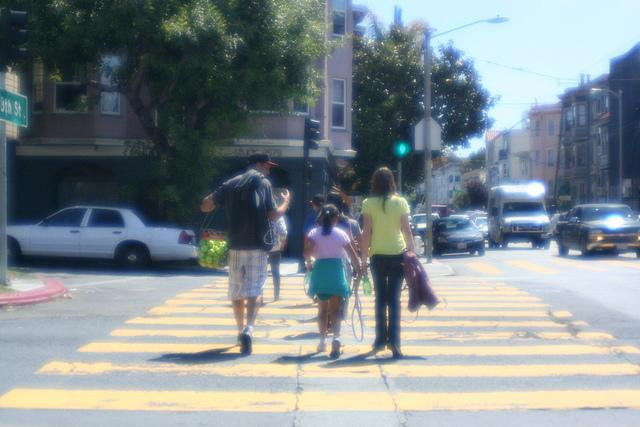How many people can be seen? six 